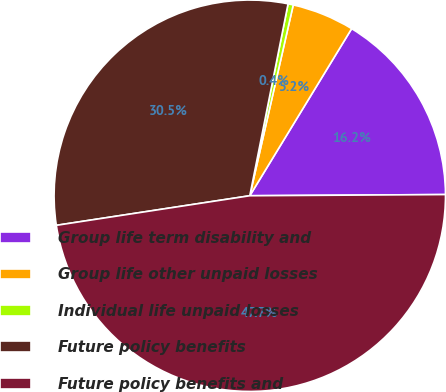Convert chart to OTSL. <chart><loc_0><loc_0><loc_500><loc_500><pie_chart><fcel>Group life term disability and<fcel>Group life other unpaid losses<fcel>Individual life unpaid losses<fcel>Future policy benefits<fcel>Future policy benefits and<nl><fcel>16.19%<fcel>5.15%<fcel>0.43%<fcel>30.55%<fcel>47.68%<nl></chart> 